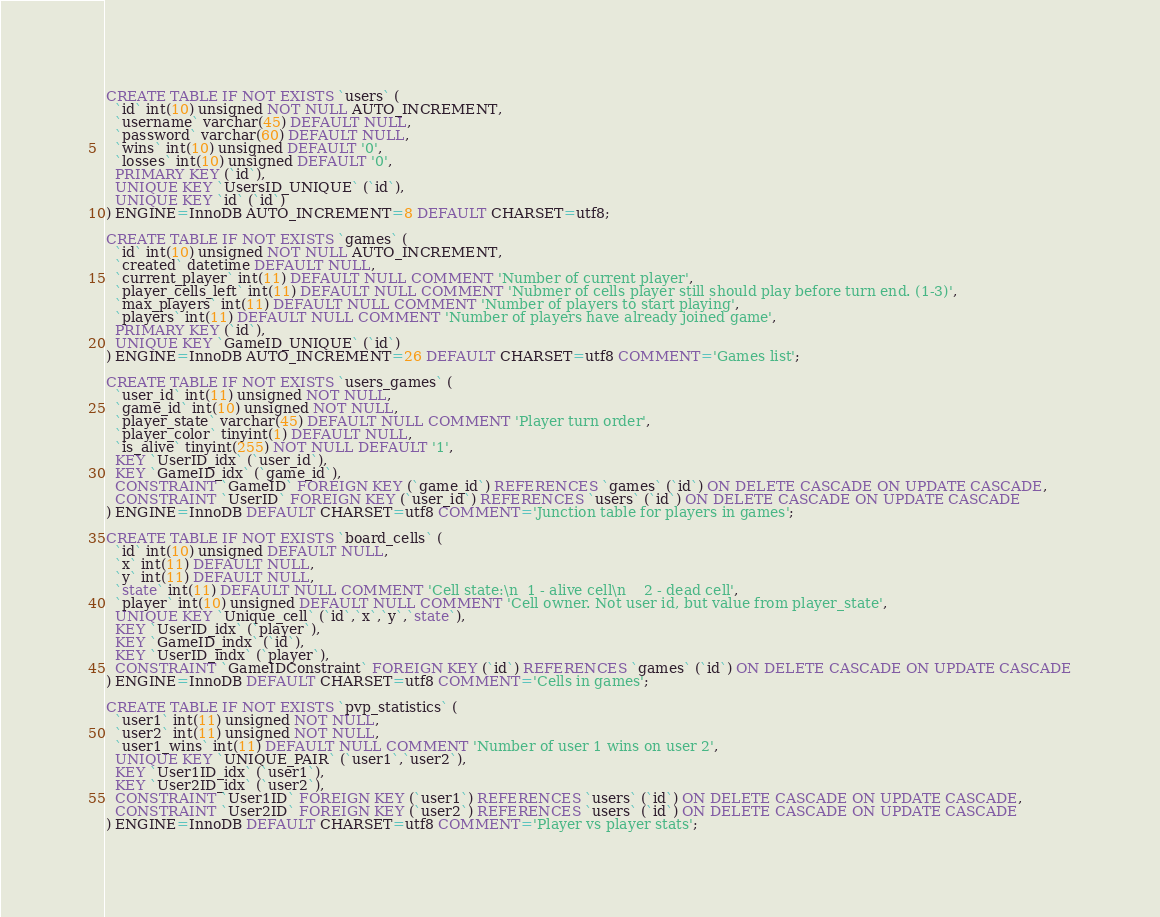<code> <loc_0><loc_0><loc_500><loc_500><_SQL_>CREATE TABLE IF NOT EXISTS `users` (
  `id` int(10) unsigned NOT NULL AUTO_INCREMENT,
  `username` varchar(45) DEFAULT NULL,
  `password` varchar(60) DEFAULT NULL,
  `wins` int(10) unsigned DEFAULT '0',
  `losses` int(10) unsigned DEFAULT '0',
  PRIMARY KEY (`id`),
  UNIQUE KEY `UsersID_UNIQUE` (`id`),
  UNIQUE KEY `id` (`id`)
) ENGINE=InnoDB AUTO_INCREMENT=8 DEFAULT CHARSET=utf8;

CREATE TABLE IF NOT EXISTS `games` (
  `id` int(10) unsigned NOT NULL AUTO_INCREMENT,
  `created` datetime DEFAULT NULL,
  `current_player` int(11) DEFAULT NULL COMMENT 'Number of current player',
  `player_cells_left` int(11) DEFAULT NULL COMMENT 'Nubmer of cells player still should play before turn end. (1-3)',
  `max_players` int(11) DEFAULT NULL COMMENT 'Number of players to start playing',
  `players` int(11) DEFAULT NULL COMMENT 'Number of players have already joined game',
  PRIMARY KEY (`id`),
  UNIQUE KEY `GameID_UNIQUE` (`id`)
) ENGINE=InnoDB AUTO_INCREMENT=26 DEFAULT CHARSET=utf8 COMMENT='Games list';

CREATE TABLE IF NOT EXISTS `users_games` (
  `user_id` int(11) unsigned NOT NULL,
  `game_id` int(10) unsigned NOT NULL,
  `player_state` varchar(45) DEFAULT NULL COMMENT 'Player turn order',
  `player_color` tinyint(1) DEFAULT NULL,
  `is_alive` tinyint(255) NOT NULL DEFAULT '1',
  KEY `UserID_idx` (`user_id`),
  KEY `GameID_idx` (`game_id`),
  CONSTRAINT `GameID` FOREIGN KEY (`game_id`) REFERENCES `games` (`id`) ON DELETE CASCADE ON UPDATE CASCADE,
  CONSTRAINT `UserID` FOREIGN KEY (`user_id`) REFERENCES `users` (`id`) ON DELETE CASCADE ON UPDATE CASCADE
) ENGINE=InnoDB DEFAULT CHARSET=utf8 COMMENT='Junction table for players in games';

CREATE TABLE IF NOT EXISTS `board_cells` (
  `id` int(10) unsigned DEFAULT NULL,
  `x` int(11) DEFAULT NULL,
  `y` int(11) DEFAULT NULL,
  `state` int(11) DEFAULT NULL COMMENT 'Cell state:\n	1 - alive cell\n	2 - dead cell',
  `player` int(10) unsigned DEFAULT NULL COMMENT 'Cell owner. Not user id, but value from player_state',
  UNIQUE KEY `Unique_cell` (`id`,`x`,`y`,`state`),
  KEY `UserID_idx` (`player`),
  KEY `GameID_indx` (`id`),
  KEY `UserID_indx` (`player`),
  CONSTRAINT `GameIDConstraint` FOREIGN KEY (`id`) REFERENCES `games` (`id`) ON DELETE CASCADE ON UPDATE CASCADE
) ENGINE=InnoDB DEFAULT CHARSET=utf8 COMMENT='Cells in games';

CREATE TABLE IF NOT EXISTS `pvp_statistics` (
  `user1` int(11) unsigned NOT NULL,
  `user2` int(11) unsigned NOT NULL,
  `user1_wins` int(11) DEFAULT NULL COMMENT 'Number of user 1 wins on user 2',
  UNIQUE KEY `UNIQUE_PAIR` (`user1`,`user2`),
  KEY `User1ID_idx` (`user1`),
  KEY `User2ID_idx` (`user2`),
  CONSTRAINT `User1ID` FOREIGN KEY (`user1`) REFERENCES `users` (`id`) ON DELETE CASCADE ON UPDATE CASCADE,
  CONSTRAINT `User2ID` FOREIGN KEY (`user2`) REFERENCES `users` (`id`) ON DELETE CASCADE ON UPDATE CASCADE
) ENGINE=InnoDB DEFAULT CHARSET=utf8 COMMENT='Player vs player stats';</code> 